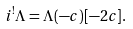<formula> <loc_0><loc_0><loc_500><loc_500>i ^ { ! } \Lambda = \Lambda ( - c ) [ - 2 c ] .</formula> 